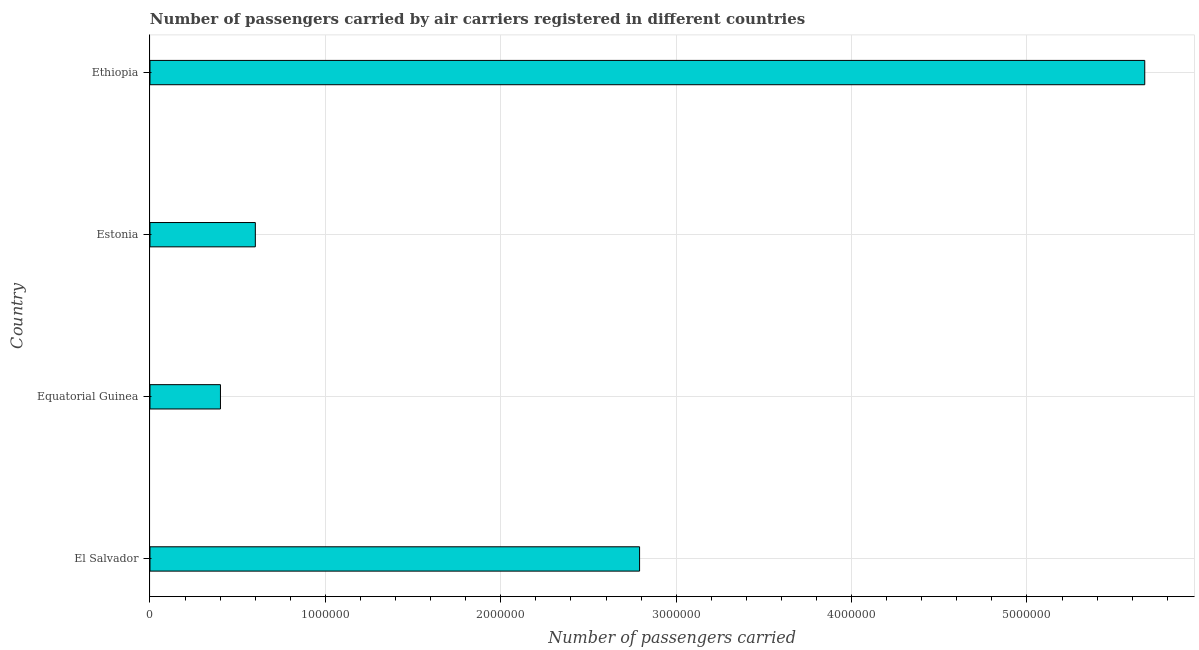What is the title of the graph?
Provide a succinct answer. Number of passengers carried by air carriers registered in different countries. What is the label or title of the X-axis?
Your answer should be compact. Number of passengers carried. What is the label or title of the Y-axis?
Your answer should be very brief. Country. What is the number of passengers carried in Estonia?
Offer a terse response. 6.01e+05. Across all countries, what is the maximum number of passengers carried?
Make the answer very short. 5.67e+06. Across all countries, what is the minimum number of passengers carried?
Make the answer very short. 4.02e+05. In which country was the number of passengers carried maximum?
Provide a short and direct response. Ethiopia. In which country was the number of passengers carried minimum?
Keep it short and to the point. Equatorial Guinea. What is the sum of the number of passengers carried?
Give a very brief answer. 9.47e+06. What is the difference between the number of passengers carried in Estonia and Ethiopia?
Your answer should be compact. -5.07e+06. What is the average number of passengers carried per country?
Make the answer very short. 2.37e+06. What is the median number of passengers carried?
Ensure brevity in your answer.  1.70e+06. In how many countries, is the number of passengers carried greater than 1800000 ?
Give a very brief answer. 2. What is the ratio of the number of passengers carried in Equatorial Guinea to that in Estonia?
Your answer should be very brief. 0.67. Is the number of passengers carried in El Salvador less than that in Ethiopia?
Provide a succinct answer. Yes. Is the difference between the number of passengers carried in El Salvador and Equatorial Guinea greater than the difference between any two countries?
Offer a terse response. No. What is the difference between the highest and the second highest number of passengers carried?
Your answer should be compact. 2.88e+06. What is the difference between the highest and the lowest number of passengers carried?
Ensure brevity in your answer.  5.27e+06. In how many countries, is the number of passengers carried greater than the average number of passengers carried taken over all countries?
Your answer should be very brief. 2. Are all the bars in the graph horizontal?
Give a very brief answer. Yes. How many countries are there in the graph?
Your response must be concise. 4. Are the values on the major ticks of X-axis written in scientific E-notation?
Ensure brevity in your answer.  No. What is the Number of passengers carried in El Salvador?
Give a very brief answer. 2.79e+06. What is the Number of passengers carried of Equatorial Guinea?
Offer a terse response. 4.02e+05. What is the Number of passengers carried in Estonia?
Offer a very short reply. 6.01e+05. What is the Number of passengers carried of Ethiopia?
Your answer should be compact. 5.67e+06. What is the difference between the Number of passengers carried in El Salvador and Equatorial Guinea?
Make the answer very short. 2.39e+06. What is the difference between the Number of passengers carried in El Salvador and Estonia?
Offer a very short reply. 2.19e+06. What is the difference between the Number of passengers carried in El Salvador and Ethiopia?
Offer a very short reply. -2.88e+06. What is the difference between the Number of passengers carried in Equatorial Guinea and Estonia?
Provide a succinct answer. -1.99e+05. What is the difference between the Number of passengers carried in Equatorial Guinea and Ethiopia?
Offer a very short reply. -5.27e+06. What is the difference between the Number of passengers carried in Estonia and Ethiopia?
Your response must be concise. -5.07e+06. What is the ratio of the Number of passengers carried in El Salvador to that in Equatorial Guinea?
Your answer should be very brief. 6.95. What is the ratio of the Number of passengers carried in El Salvador to that in Estonia?
Offer a very short reply. 4.65. What is the ratio of the Number of passengers carried in El Salvador to that in Ethiopia?
Offer a very short reply. 0.49. What is the ratio of the Number of passengers carried in Equatorial Guinea to that in Estonia?
Give a very brief answer. 0.67. What is the ratio of the Number of passengers carried in Equatorial Guinea to that in Ethiopia?
Make the answer very short. 0.07. What is the ratio of the Number of passengers carried in Estonia to that in Ethiopia?
Offer a very short reply. 0.11. 